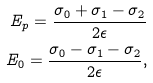<formula> <loc_0><loc_0><loc_500><loc_500>E _ { p } = \frac { \sigma _ { 0 } + \sigma _ { 1 } - \sigma _ { 2 } } { 2 \epsilon } \\ E _ { 0 } = \frac { \sigma _ { 0 } - \sigma _ { 1 } - \sigma _ { 2 } } { 2 \epsilon } ,</formula> 